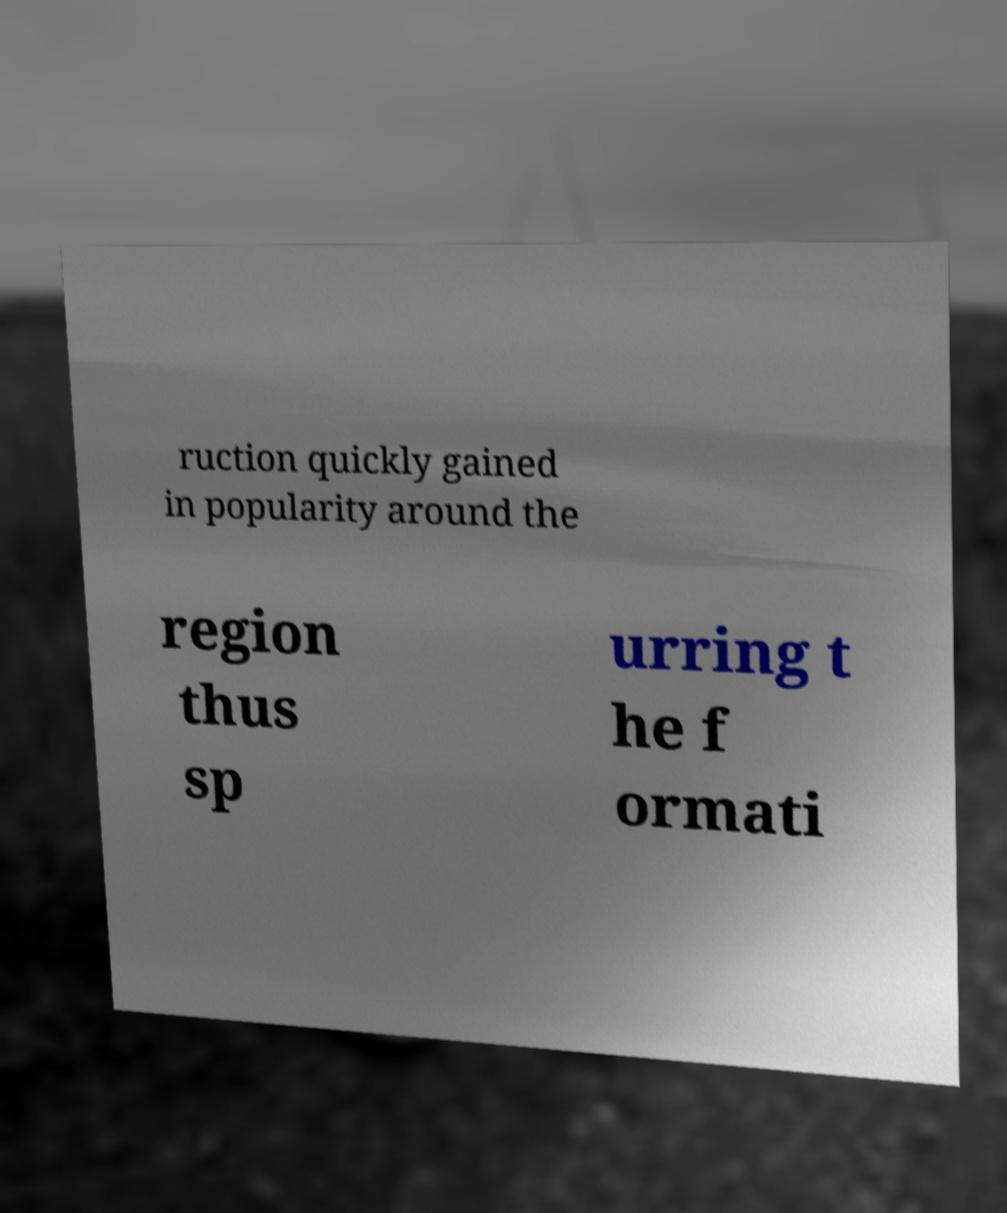Can you accurately transcribe the text from the provided image for me? ruction quickly gained in popularity around the region thus sp urring t he f ormati 